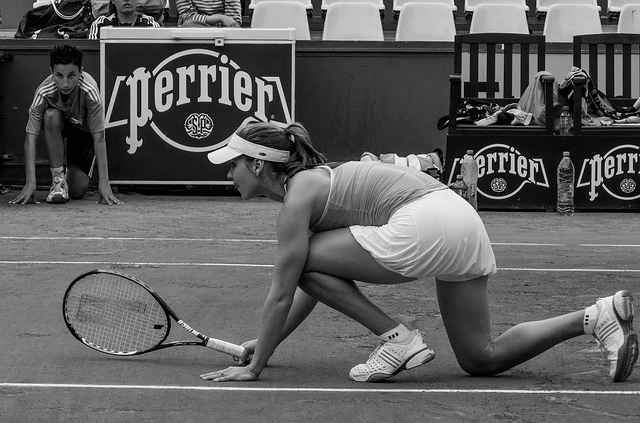Please transcribe the text in this image. perrier SP ERRIER Perr 